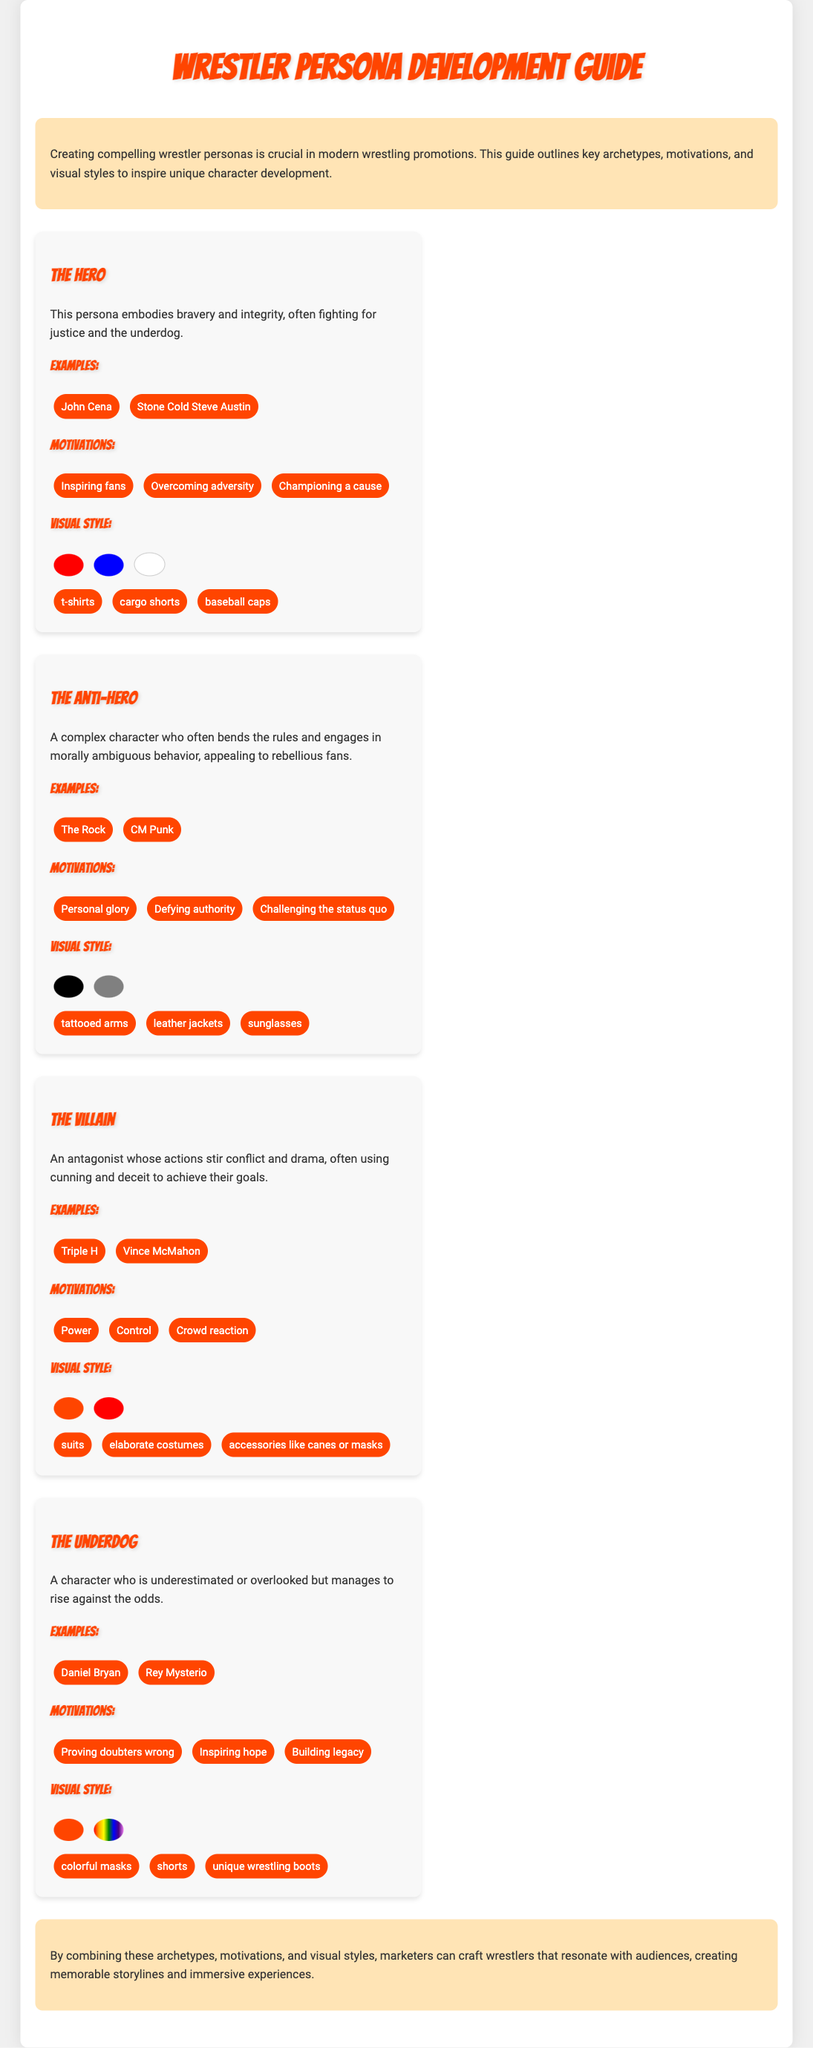What is the title of the document? The title is prominently displayed at the top of the document, presenting the guide's focus.
Answer: Wrestler Persona Development Guide Who is an example of "The Hero" archetype? The document lists notable wrestlers associated with each archetype, including "The Hero."
Answer: John Cena What motivation is associated with "The Villain"? Each archetype includes a list of motivations that drive the characters; for villains, power is a key motivation.
Answer: Power What is a visual style element of "The Anti-Hero"? The document details specific visual elements that characterize each persona, including tattoos for the anti-hero.
Answer: tattooed arms How many archetypes are mentioned in the document? The document outlines four distinct archetypes in total.
Answer: 4 What color is associated with "The Underdog"? The visual styles of the underdog include specific colors that serve as identifiers.
Answer: neon Which persona is characterized by engaging in morally ambiguous behavior? This behavior is specifically described in relation to one of the archetypes in the guide.
Answer: The Anti-Hero What concluding message does the document convey? The conclusion emphasizes the importance of combining elements for effective marketing.
Answer: resonate with audiences 